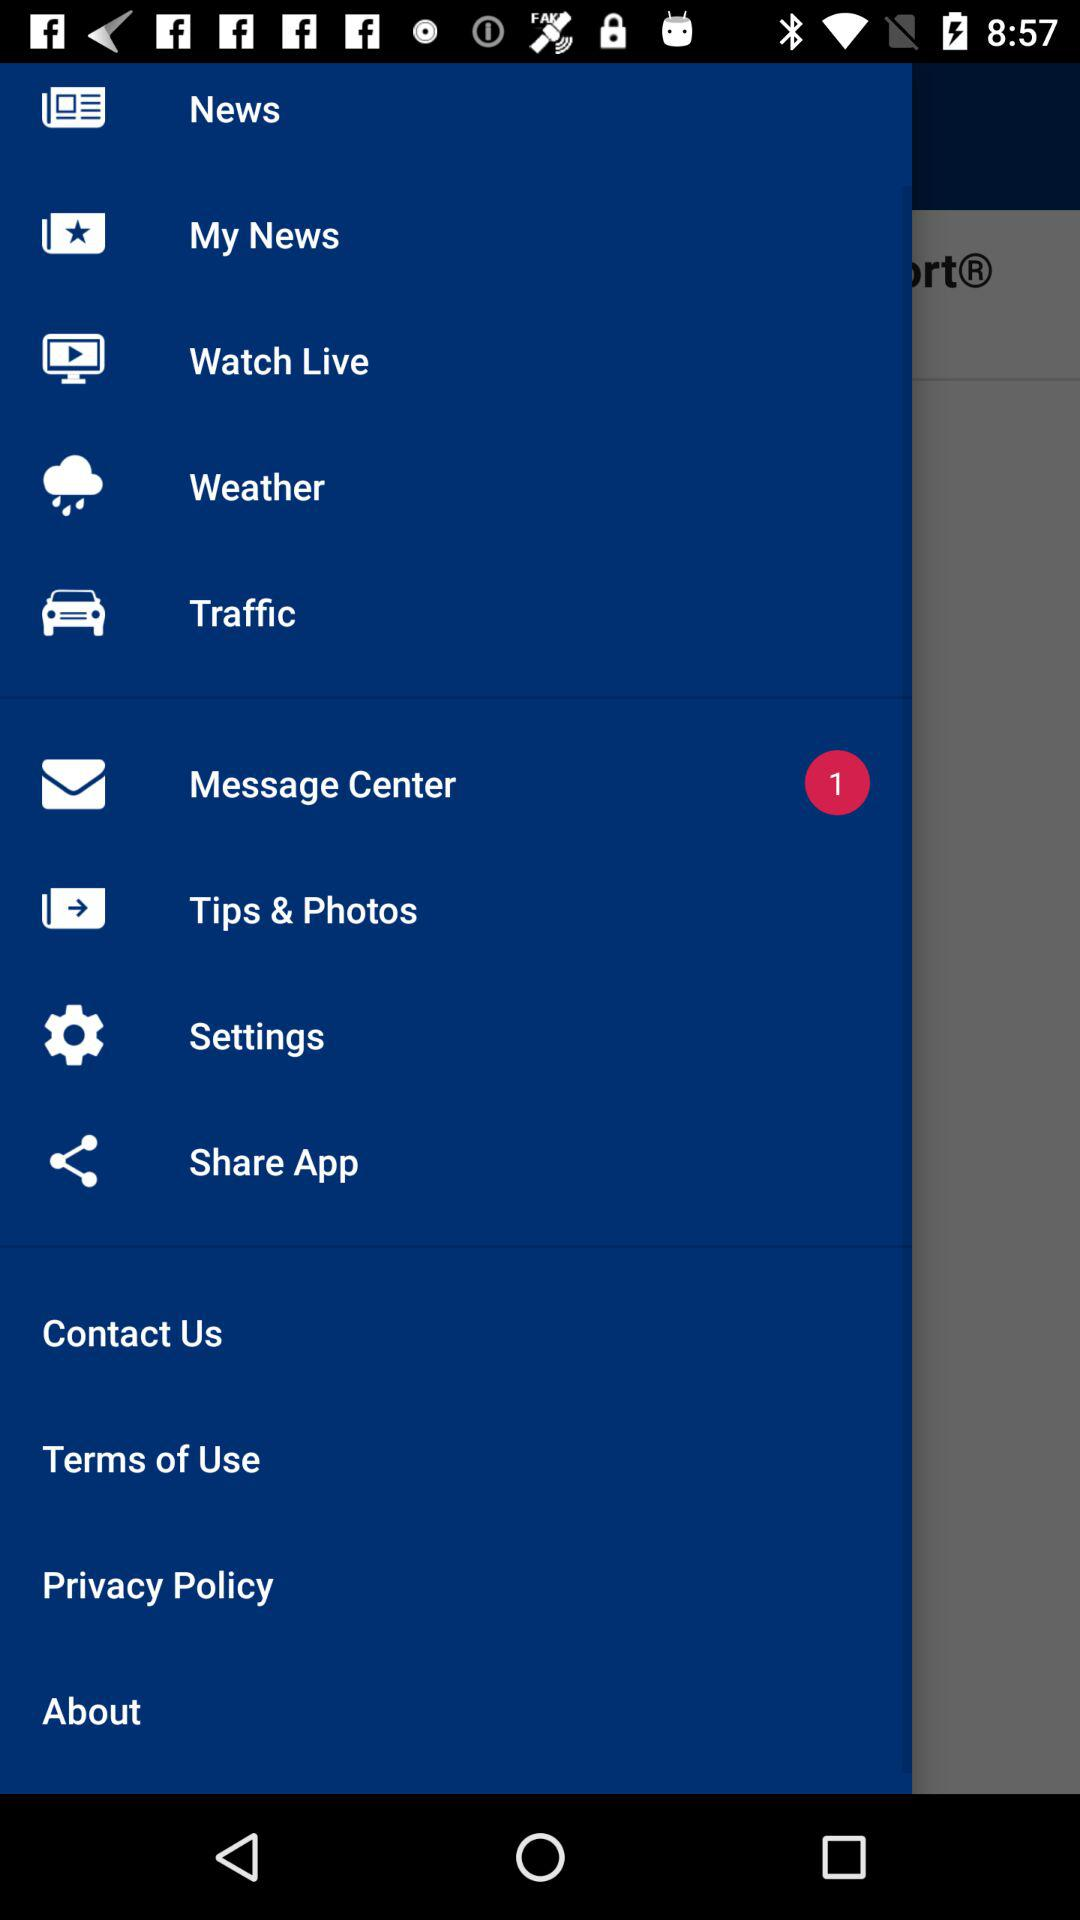How many items have red circles with numbers in them?
Answer the question using a single word or phrase. 1 